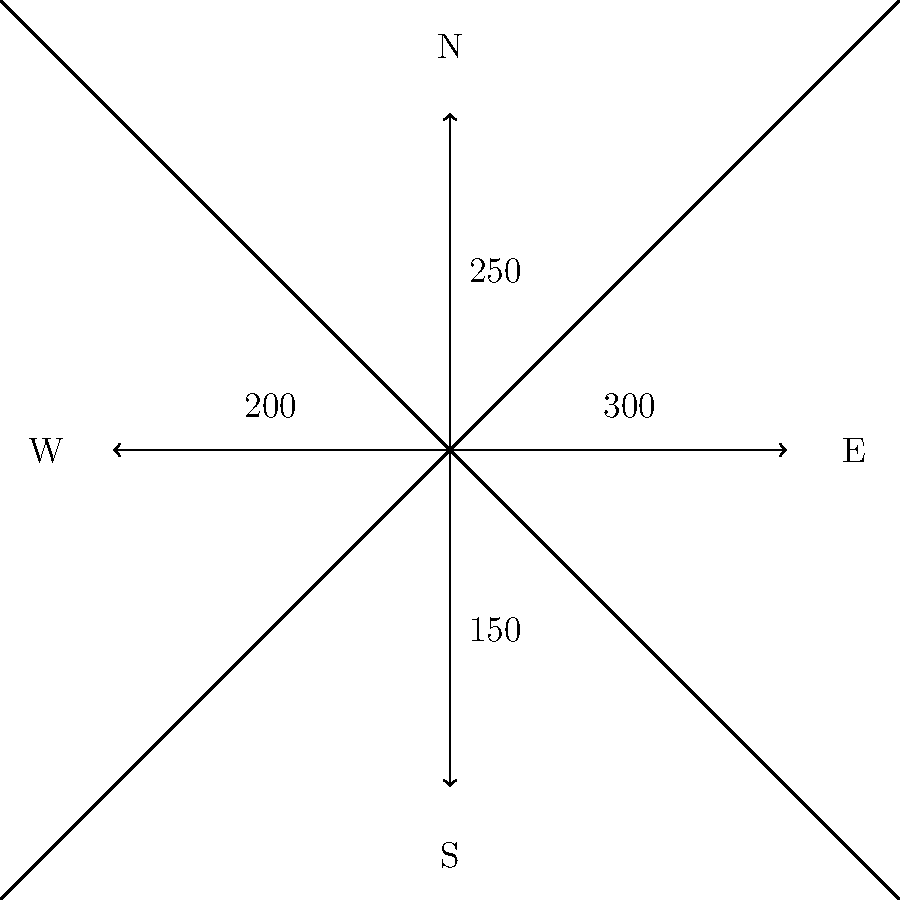Based on the traffic flow diagram for a major intersection in our city, which direction has the highest volume of traffic, and what strategy would you recommend to alleviate congestion in that direction? To answer this question, we need to analyze the traffic flow diagram and interpret the data provided:

1. The diagram shows traffic flow in four directions: North, South, East, and West.
2. Each arrow represents the traffic volume in its respective direction:
   - East: 300 vehicles
   - North: 250 vehicles
   - West: 200 vehicles
   - South: 150 vehicles

3. The highest volume of traffic is in the East direction, with 300 vehicles.

4. To alleviate congestion in the eastbound direction, we could consider the following strategies:

   a) Implement traffic signal timing adjustments to allow longer green light durations for eastbound traffic during peak hours.
   
   b) Add an additional lane or widen the existing lanes in the eastbound direction to increase capacity.
   
   c) Encourage alternative routes for drivers heading east to distribute traffic more evenly.
   
   d) Implement reversible lanes that can adapt to traffic flow during different times of the day.
   
   e) Promote public transportation options or carpooling initiatives to reduce the number of individual vehicles on the road.

5. The most effective immediate solution would be to adjust traffic signal timing, as it can be implemented quickly and with minimal cost.

Therefore, the recommended strategy would be to adjust traffic signal timing to favor eastbound traffic during peak hours.
Answer: Adjust traffic signal timing for eastbound traffic 